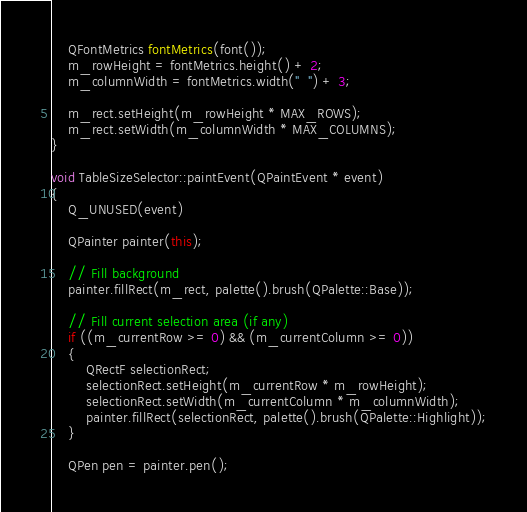<code> <loc_0><loc_0><loc_500><loc_500><_C++_>
    QFontMetrics fontMetrics(font());
    m_rowHeight = fontMetrics.height() + 2;
    m_columnWidth = fontMetrics.width("  ") + 3;

    m_rect.setHeight(m_rowHeight * MAX_ROWS);
    m_rect.setWidth(m_columnWidth * MAX_COLUMNS);
}

void TableSizeSelector::paintEvent(QPaintEvent * event)
{
    Q_UNUSED(event)

    QPainter painter(this);

    // Fill background
    painter.fillRect(m_rect, palette().brush(QPalette::Base));

    // Fill current selection area (if any)
    if ((m_currentRow >= 0) && (m_currentColumn >= 0))
    {
        QRectF selectionRect;
        selectionRect.setHeight(m_currentRow * m_rowHeight);
        selectionRect.setWidth(m_currentColumn * m_columnWidth);
        painter.fillRect(selectionRect, palette().brush(QPalette::Highlight));
    }

    QPen pen = painter.pen();</code> 